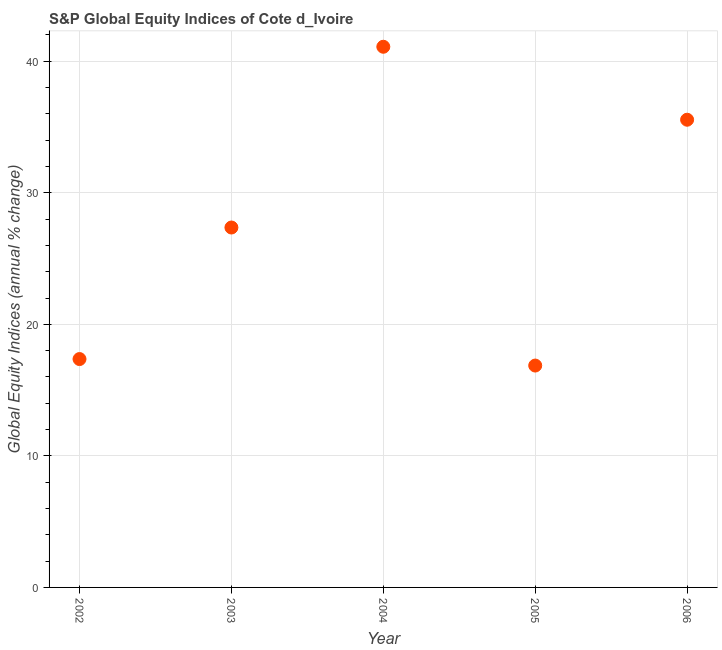What is the s&p global equity indices in 2006?
Keep it short and to the point. 35.55. Across all years, what is the maximum s&p global equity indices?
Your answer should be compact. 41.1. Across all years, what is the minimum s&p global equity indices?
Your answer should be compact. 16.87. In which year was the s&p global equity indices maximum?
Offer a very short reply. 2004. In which year was the s&p global equity indices minimum?
Give a very brief answer. 2005. What is the sum of the s&p global equity indices?
Provide a succinct answer. 138.24. What is the difference between the s&p global equity indices in 2003 and 2004?
Offer a very short reply. -13.74. What is the average s&p global equity indices per year?
Provide a succinct answer. 27.65. What is the median s&p global equity indices?
Your response must be concise. 27.36. In how many years, is the s&p global equity indices greater than 10 %?
Your answer should be very brief. 5. Do a majority of the years between 2005 and 2006 (inclusive) have s&p global equity indices greater than 28 %?
Give a very brief answer. No. What is the ratio of the s&p global equity indices in 2002 to that in 2003?
Provide a succinct answer. 0.63. What is the difference between the highest and the second highest s&p global equity indices?
Provide a succinct answer. 5.55. Is the sum of the s&p global equity indices in 2002 and 2006 greater than the maximum s&p global equity indices across all years?
Provide a succinct answer. Yes. What is the difference between the highest and the lowest s&p global equity indices?
Your answer should be compact. 24.23. In how many years, is the s&p global equity indices greater than the average s&p global equity indices taken over all years?
Offer a terse response. 2. How many dotlines are there?
Your answer should be very brief. 1. How many years are there in the graph?
Your answer should be compact. 5. Does the graph contain any zero values?
Keep it short and to the point. No. What is the title of the graph?
Offer a terse response. S&P Global Equity Indices of Cote d_Ivoire. What is the label or title of the X-axis?
Ensure brevity in your answer.  Year. What is the label or title of the Y-axis?
Provide a short and direct response. Global Equity Indices (annual % change). What is the Global Equity Indices (annual % change) in 2002?
Make the answer very short. 17.36. What is the Global Equity Indices (annual % change) in 2003?
Your answer should be very brief. 27.36. What is the Global Equity Indices (annual % change) in 2004?
Your answer should be compact. 41.1. What is the Global Equity Indices (annual % change) in 2005?
Provide a succinct answer. 16.87. What is the Global Equity Indices (annual % change) in 2006?
Keep it short and to the point. 35.55. What is the difference between the Global Equity Indices (annual % change) in 2002 and 2003?
Give a very brief answer. -10. What is the difference between the Global Equity Indices (annual % change) in 2002 and 2004?
Make the answer very short. -23.74. What is the difference between the Global Equity Indices (annual % change) in 2002 and 2005?
Keep it short and to the point. 0.49. What is the difference between the Global Equity Indices (annual % change) in 2002 and 2006?
Make the answer very short. -18.19. What is the difference between the Global Equity Indices (annual % change) in 2003 and 2004?
Your answer should be compact. -13.74. What is the difference between the Global Equity Indices (annual % change) in 2003 and 2005?
Give a very brief answer. 10.49. What is the difference between the Global Equity Indices (annual % change) in 2003 and 2006?
Your answer should be compact. -8.19. What is the difference between the Global Equity Indices (annual % change) in 2004 and 2005?
Give a very brief answer. 24.23. What is the difference between the Global Equity Indices (annual % change) in 2004 and 2006?
Your answer should be compact. 5.55. What is the difference between the Global Equity Indices (annual % change) in 2005 and 2006?
Keep it short and to the point. -18.69. What is the ratio of the Global Equity Indices (annual % change) in 2002 to that in 2003?
Keep it short and to the point. 0.64. What is the ratio of the Global Equity Indices (annual % change) in 2002 to that in 2004?
Your response must be concise. 0.42. What is the ratio of the Global Equity Indices (annual % change) in 2002 to that in 2005?
Your response must be concise. 1.03. What is the ratio of the Global Equity Indices (annual % change) in 2002 to that in 2006?
Your answer should be very brief. 0.49. What is the ratio of the Global Equity Indices (annual % change) in 2003 to that in 2004?
Your answer should be very brief. 0.67. What is the ratio of the Global Equity Indices (annual % change) in 2003 to that in 2005?
Provide a short and direct response. 1.62. What is the ratio of the Global Equity Indices (annual % change) in 2003 to that in 2006?
Your answer should be compact. 0.77. What is the ratio of the Global Equity Indices (annual % change) in 2004 to that in 2005?
Offer a terse response. 2.44. What is the ratio of the Global Equity Indices (annual % change) in 2004 to that in 2006?
Your response must be concise. 1.16. What is the ratio of the Global Equity Indices (annual % change) in 2005 to that in 2006?
Offer a very short reply. 0.47. 